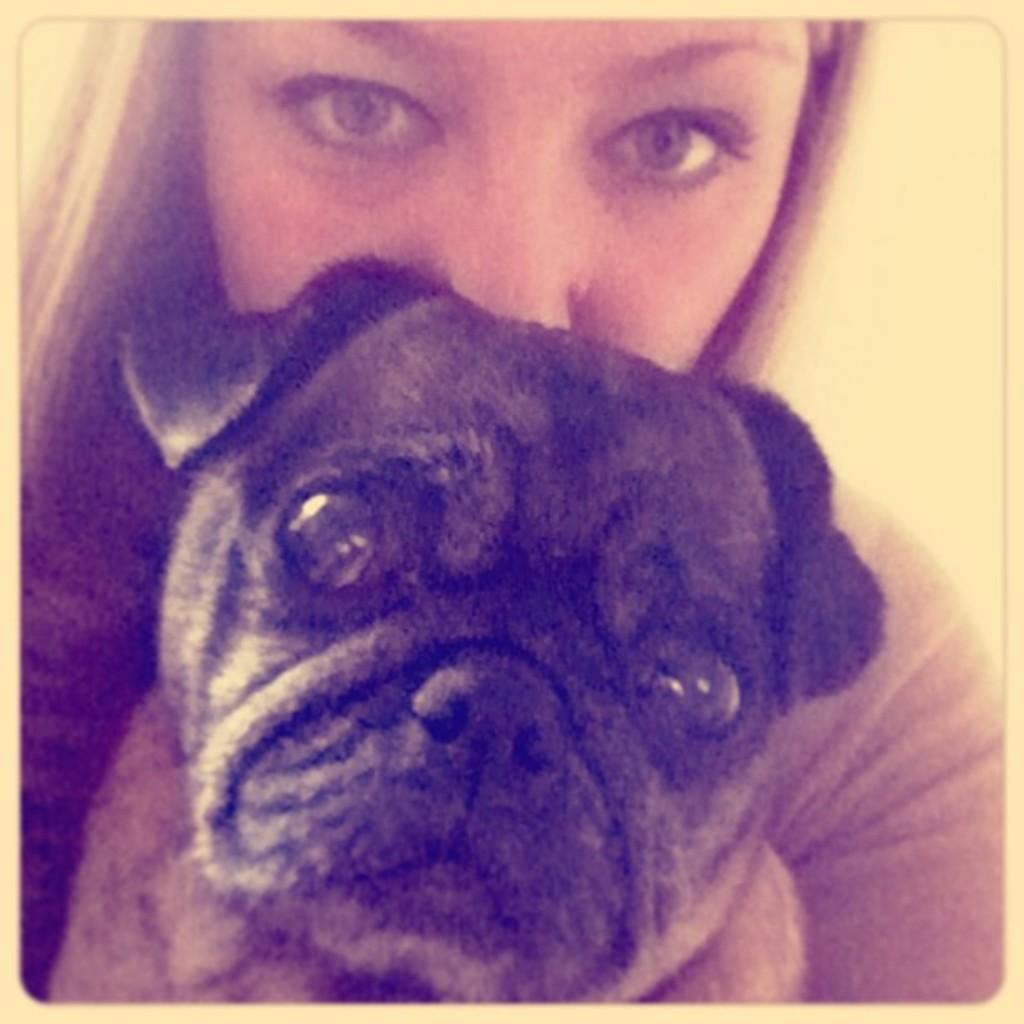What is the main subject of the image? The main subject of the image is a dog's face. Can you describe the color of the dog's face? The dog's face is in black color. Who else is present in the image besides the dog? There is a woman in the image. What is the woman wearing? The woman is wearing a white dress. Is there a veil visible on the dog's face in the image? No, there is no veil present on the dog's face in the image. What type of square object can be seen in the image? There is no square object present in the image. 